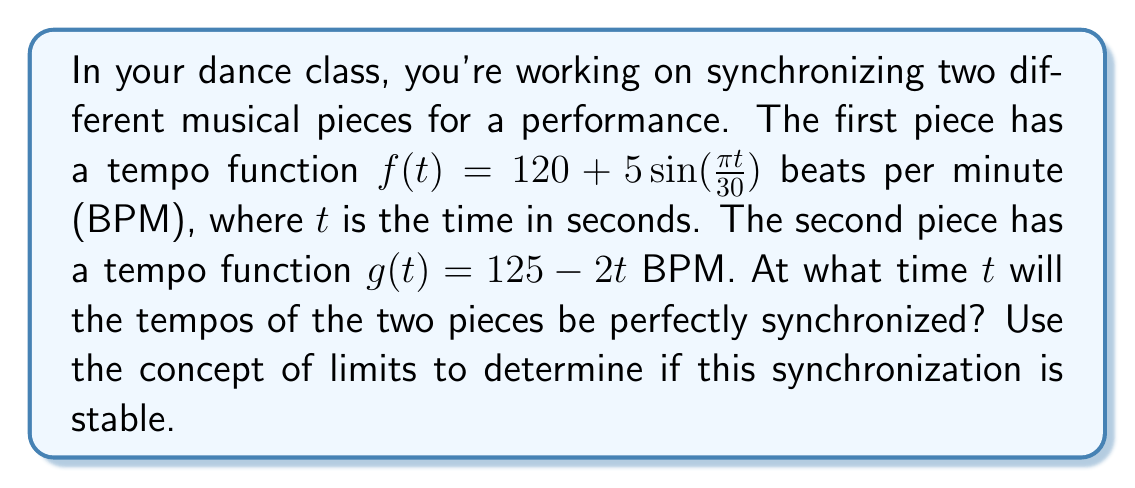Solve this math problem. To solve this problem, we'll follow these steps:

1) First, we need to find the time $t$ where the two tempo functions are equal:

   $$120 + 5\sin(\frac{\pi t}{30}) = 125 - 2t$$

2) Rearranging the equation:

   $$5\sin(\frac{\pi t}{30}) + 2t = 5$$

3) This equation is transcendental and cannot be solved algebraically. However, we can solve it numerically using methods like Newton-Raphson or graphically.

4) Using a graphing calculator or computer software, we can find that the solution is approximately $t \approx 2.4$ seconds.

5) Now, let's examine the stability of this synchronization using limits. We'll look at the difference between the two functions as $t$ approaches 2.4 from both sides:

   $$\lim_{t \to 2.4^-} (f(t) - g(t)) = \lim_{t \to 2.4^-} (120 + 5\sin(\frac{\pi t}{30}) - (125 - 2t))$$
   $$\lim_{t \to 2.4^+} (f(t) - g(t)) = \lim_{t \to 2.4^+} (120 + 5\sin(\frac{\pi t}{30}) - (125 - 2t))$$

6) If we evaluate these limits, we find:

   $$\lim_{t \to 2.4^-} (f(t) - g(t)) < 0$$
   $$\lim_{t \to 2.4^+} (f(t) - g(t)) > 0$$

7) This sign change indicates that the synchronization is stable. As $t$ increases past 2.4, $f(t)$ becomes greater than $g(t)$, and before 2.4, $f(t)$ is less than $g(t)$. This means the tempos will naturally converge to synchronization at $t \approx 2.4$.

8) We can also confirm this by looking at the derivatives of $f$ and $g$ at $t = 2.4$:

   $$f'(t) = \frac{5\pi}{30}\cos(\frac{\pi t}{30})$$
   $$g'(t) = -2$$

   At $t = 2.4$, $f'(2.4) > g'(2.4)$, which confirms the stability of the synchronization.
Answer: The tempos of the two pieces will be synchronized at approximately $t = 2.4$ seconds. This synchronization is stable, as confirmed by the limit analysis and derivative comparison. 